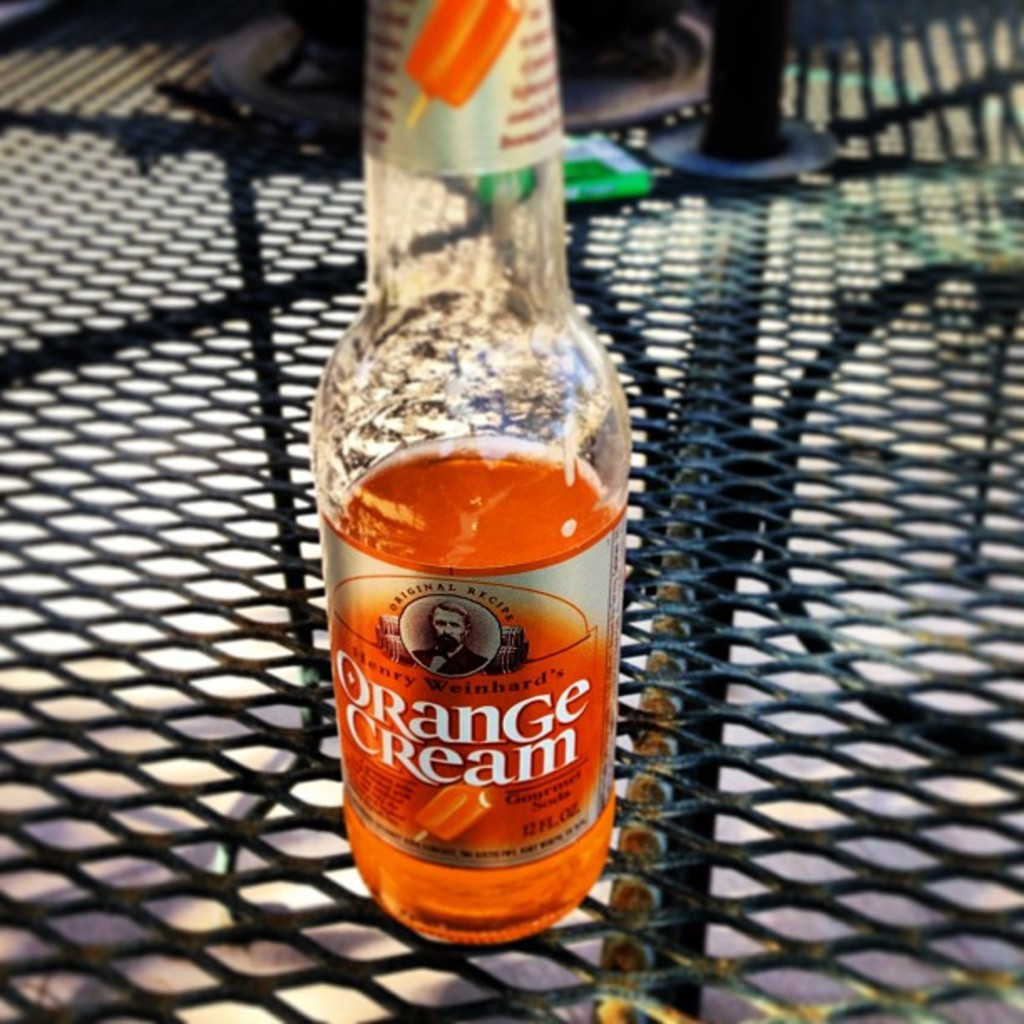What food pairings would compliment this beverage? The sweet and creamy citrus profile of this Orange Cream soda would pair splendidly with light summer fare such as a fresh arugula salad, grilled shrimp skewers, or a zesty lemon tart dessert. 